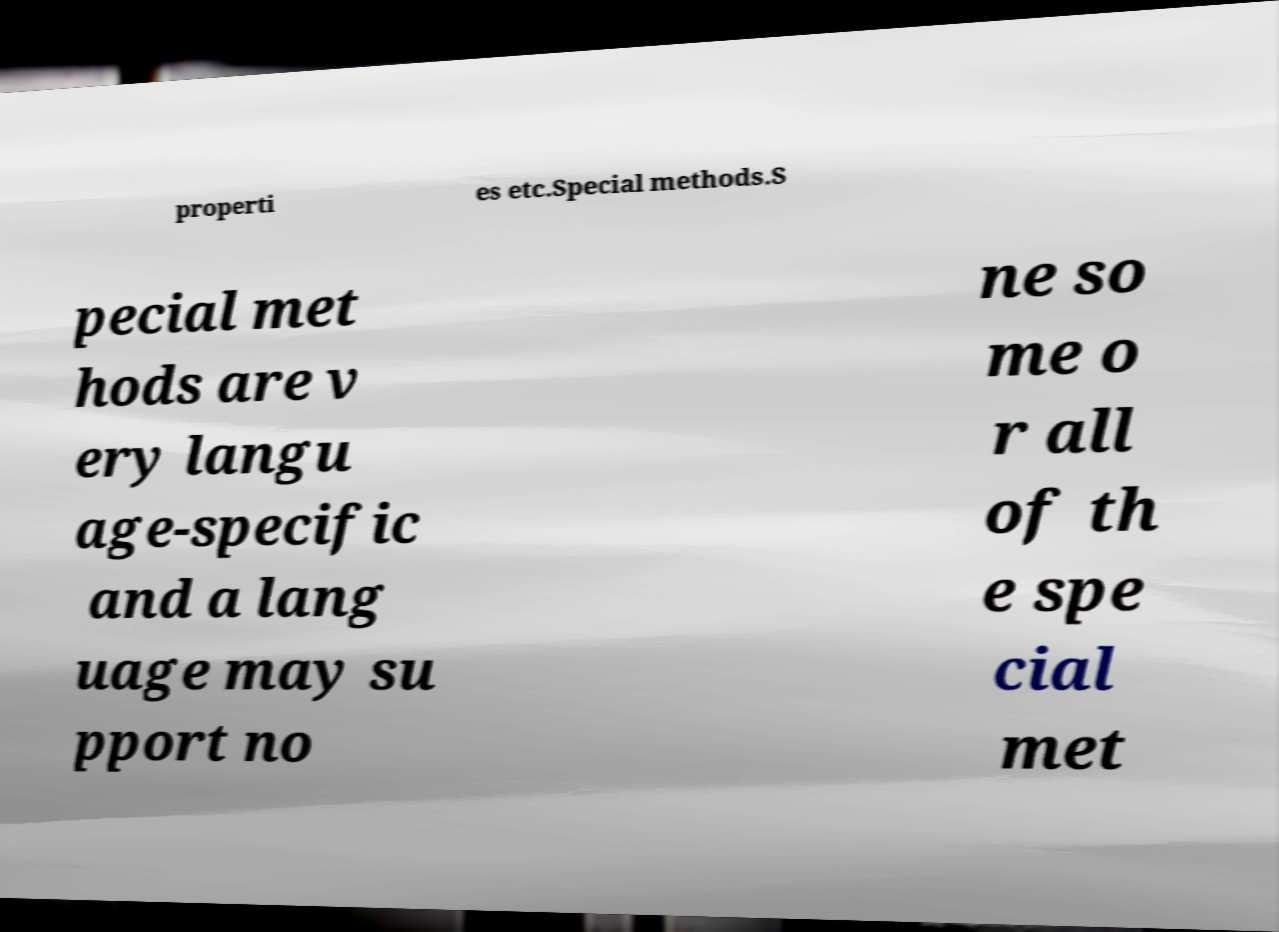What messages or text are displayed in this image? I need them in a readable, typed format. properti es etc.Special methods.S pecial met hods are v ery langu age-specific and a lang uage may su pport no ne so me o r all of th e spe cial met 